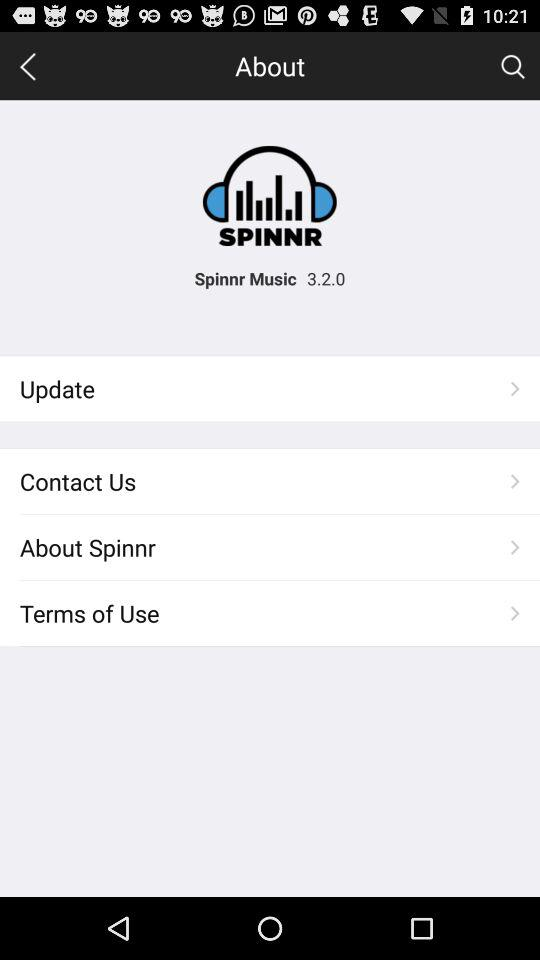What is the application name? The application name is "Spinnr Music". 